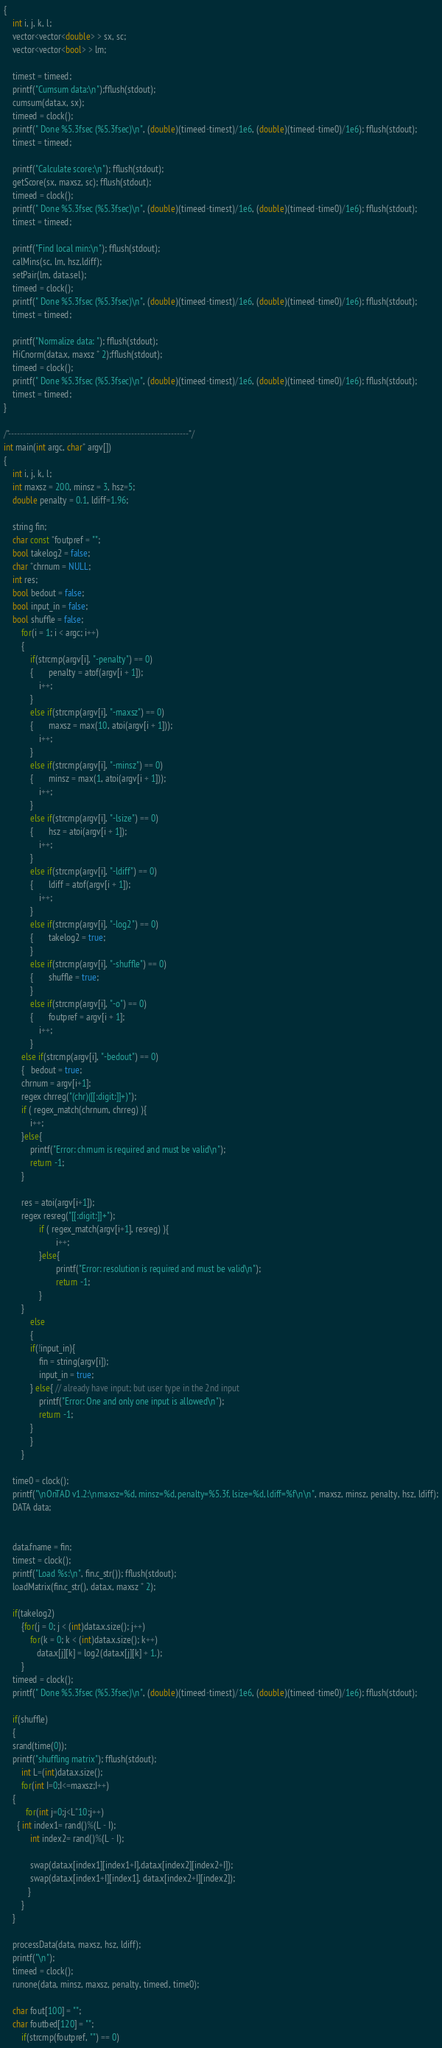<code> <loc_0><loc_0><loc_500><loc_500><_C++_>{
	int i, j, k, l;
	vector<vector<double> > sx, sc;
	vector<vector<bool> > lm;	

	timest = timeed;
	printf("Cumsum data:\n");fflush(stdout);
	cumsum(data.x, sx);
	timeed = clock();
	printf(" Done %5.3fsec (%5.3fsec)\n", (double)(timeed-timest)/1e6, (double)(timeed-time0)/1e6); fflush(stdout);
	timest = timeed;
	
	printf("Calculate score:\n"); fflush(stdout);
	getScore(sx, maxsz, sc); fflush(stdout);
	timeed = clock();
	printf(" Done %5.3fsec (%5.3fsec)\n", (double)(timeed-timest)/1e6, (double)(timeed-time0)/1e6); fflush(stdout);
	timest = timeed;

	printf("Find local min:\n"); fflush(stdout);
	calMins(sc, lm, hsz,ldiff);
	setPair(lm, data.sel);
	timeed = clock();
	printf(" Done %5.3fsec (%5.3fsec)\n", (double)(timeed-timest)/1e6, (double)(timeed-time0)/1e6); fflush(stdout);
	timest = timeed;
		
	printf("Normalize data: "); fflush(stdout);
	HiCnorm(data.x, maxsz * 2);fflush(stdout);
	timeed = clock();
	printf(" Done %5.3fsec (%5.3fsec)\n", (double)(timeed-timest)/1e6, (double)(timeed-time0)/1e6); fflush(stdout);
	timest = timeed;
}

/*---------------------------------------------------------------*/
int main(int argc, char* argv[])
{
	int i, j, k, l; 
	int maxsz = 200, minsz = 3, hsz=5;
	double penalty = 0.1, ldiff=1.96;
	
	string fin;
	char const *foutpref = "";
	bool takelog2 = false;
	char *chrnum = NULL;
	int res;
	bool bedout = false;
	bool input_in = false;
	bool shuffle = false;
        for(i = 1; i < argc; i++)
        {
            if(strcmp(argv[i], "-penalty") == 0)
            {       penalty = atof(argv[i + 1]);
                i++;
            }
            else if(strcmp(argv[i], "-maxsz") == 0)
            {       maxsz = max(10, atoi(argv[i + 1]));
                i++;
            }
            else if(strcmp(argv[i], "-minsz") == 0)
            {       minsz = max(1, atoi(argv[i + 1]));
                i++;
            }
            else if(strcmp(argv[i], "-lsize") == 0)
            {       hsz = atoi(argv[i + 1]);
                i++;
            }
            else if(strcmp(argv[i], "-ldiff") == 0)
            {       ldiff = atof(argv[i + 1]);
                i++;
            }
            else if(strcmp(argv[i], "-log2") == 0)
            {       takelog2 = true;
            }
            else if(strcmp(argv[i], "-shuffle") == 0)
            {       shuffle = true;
            }
            else if(strcmp(argv[i], "-o") == 0)
            {       foutpref = argv[i + 1];
                i++;
            }
	    else if(strcmp(argv[i], "-bedout") == 0)
	    {   bedout = true;
		chrnum = argv[i+1];
		regex chrreg("(chr)([[:digit:]]+)");
		if ( regex_match(chrnum, chrreg) ){
			i++;
		}else{
			printf("Error: chrnum is required and must be valid\n");
			return -1;
		}
		
		res = atoi(argv[i+1]);
		regex resreg("[[:digit:]]+");
                if ( regex_match(argv[i+1], resreg) ){
                        i++;
                }else{
                        printf("Error: resolution is required and must be valid\n");
                        return -1;
                }
	    }
            else
            {       
        	if(!input_in){
        		fin = string(argv[i]);
        		input_in = true;
        	} else{ // already have input; but user type in the 2nd input
        		printf("Error: One and only one input is allowed\n");
				return -1;
        	}
            }
        }

	time0 = clock();
	printf("\nOnTAD v1.2:\nmaxsz=%d, minsz=%d, penalty=%5.3f, lsize=%d, ldiff=%f\n\n", maxsz, minsz, penalty, hsz, ldiff);
	DATA data;
	
	
	data.fname = fin;
	timest = clock();
	printf("Load %s:\n", fin.c_str()); fflush(stdout);
	loadMatrix(fin.c_str(), data.x, maxsz * 2);

	if(takelog2)
        {for(j = 0; j < (int)data.x.size(); j++)
            for(k = 0; k < (int)data.x.size(); k++)
               data.x[j][k] = log2(data.x[j][k] + 1.);
        }
	timeed = clock();
	printf(" Done %5.3fsec (%5.3fsec)\n", (double)(timeed-timest)/1e6, (double)(timeed-time0)/1e6); fflush(stdout);

	if(shuffle)
	{
	srand(time(0));
	printf("shuffling matrix"); fflush(stdout);
        int L=(int)data.x.size();
        for(int I=0;I<=maxsz;I++)
	{
          for(int j=0;j<L*10;j++)
  	  { int index1= rand()%(L - I);
    	    int index2= rand()%(L - I);
         
            swap(data.x[index1][index1+I],data.x[index2][index2+I]);
            swap(data.x[index1+I][index1], data.x[index2+I][index2]);
           }
        }
	}

	processData(data, maxsz, hsz, ldiff);
	printf("\n");
	timeed = clock();
	runone(data, minsz, maxsz, penalty, timeed, time0);

	char fout[100] = "";
	char foutbed[120] = "";
        if(strcmp(foutpref, "") == 0)</code> 